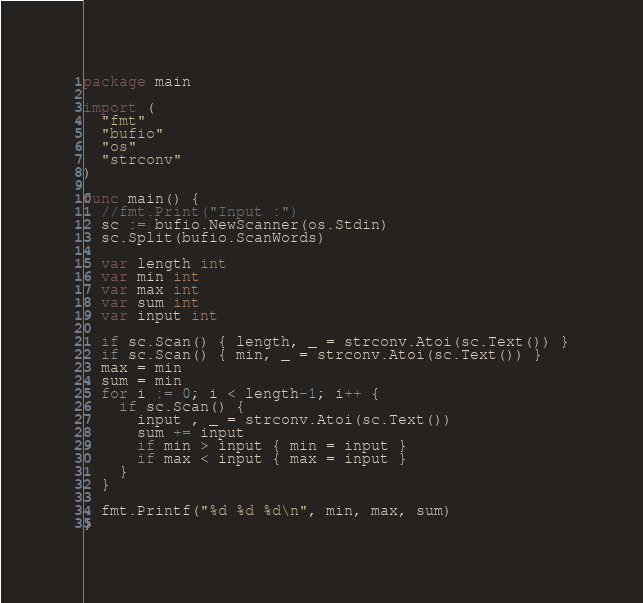<code> <loc_0><loc_0><loc_500><loc_500><_Go_>package main

import (
  "fmt"
  "bufio"
  "os"
  "strconv"
)

func main() {
  //fmt.Print("Input :")
  sc := bufio.NewScanner(os.Stdin)
  sc.Split(bufio.ScanWords)

  var length int
  var min int
  var max int
  var sum int
  var input int

  if sc.Scan() { length, _ = strconv.Atoi(sc.Text()) }
  if sc.Scan() { min, _ = strconv.Atoi(sc.Text()) }
  max = min
  sum = min
  for i := 0; i < length-1; i++ {
    if sc.Scan() {
      input , _ = strconv.Atoi(sc.Text())
      sum += input
      if min > input { min = input }
      if max < input { max = input }
    }
  }

  fmt.Printf("%d %d %d\n", min, max, sum)
}

</code> 